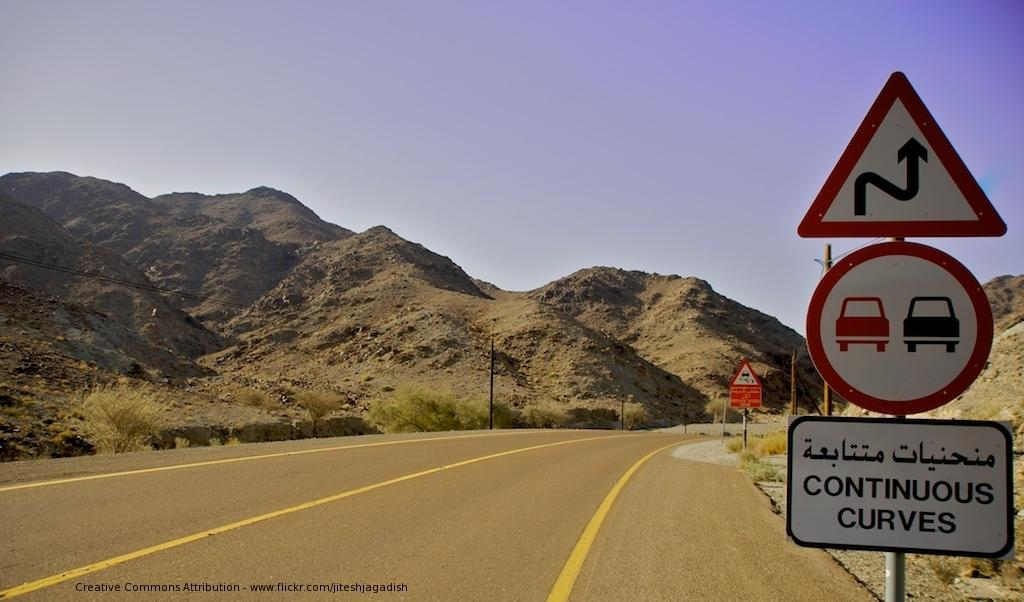<image>
Give a short and clear explanation of the subsequent image. Three road signs on the right hand side of the road indicating there are continuous curves ahead. 